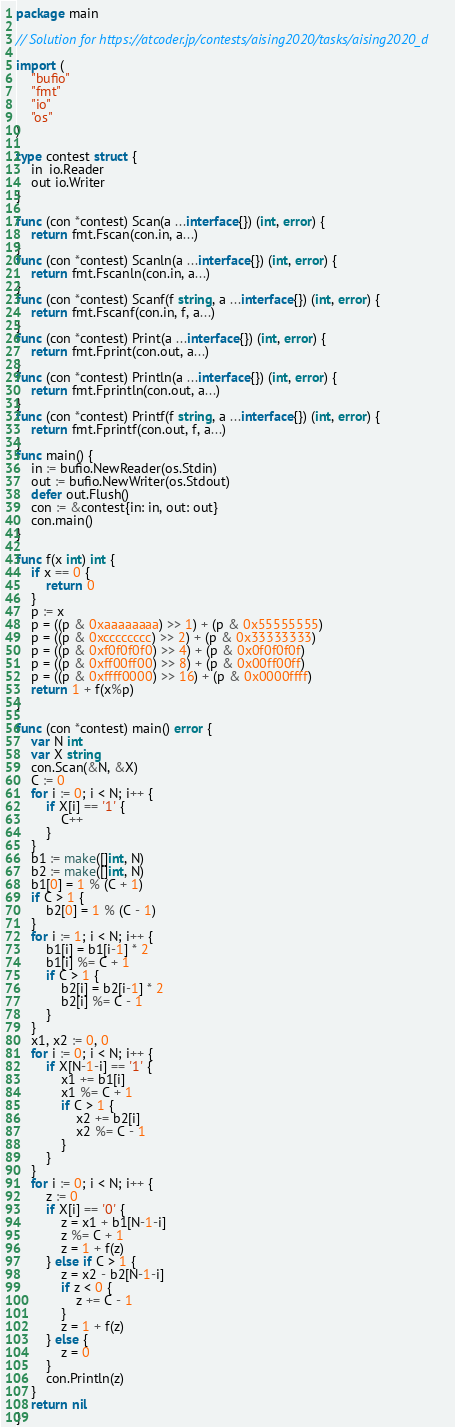Convert code to text. <code><loc_0><loc_0><loc_500><loc_500><_Go_>package main

// Solution for https://atcoder.jp/contests/aising2020/tasks/aising2020_d

import (
	"bufio"
	"fmt"
	"io"
	"os"
)

type contest struct {
	in  io.Reader
	out io.Writer
}

func (con *contest) Scan(a ...interface{}) (int, error) {
	return fmt.Fscan(con.in, a...)
}
func (con *contest) Scanln(a ...interface{}) (int, error) {
	return fmt.Fscanln(con.in, a...)
}
func (con *contest) Scanf(f string, a ...interface{}) (int, error) {
	return fmt.Fscanf(con.in, f, a...)
}
func (con *contest) Print(a ...interface{}) (int, error) {
	return fmt.Fprint(con.out, a...)
}
func (con *contest) Println(a ...interface{}) (int, error) {
	return fmt.Fprintln(con.out, a...)
}
func (con *contest) Printf(f string, a ...interface{}) (int, error) {
	return fmt.Fprintf(con.out, f, a...)
}
func main() {
	in := bufio.NewReader(os.Stdin)
	out := bufio.NewWriter(os.Stdout)
	defer out.Flush()
	con := &contest{in: in, out: out}
	con.main()
}

func f(x int) int {
	if x == 0 {
		return 0
	}
	p := x
	p = ((p & 0xaaaaaaaa) >> 1) + (p & 0x55555555)
	p = ((p & 0xcccccccc) >> 2) + (p & 0x33333333)
	p = ((p & 0xf0f0f0f0) >> 4) + (p & 0x0f0f0f0f)
	p = ((p & 0xff00ff00) >> 8) + (p & 0x00ff00ff)
	p = ((p & 0xffff0000) >> 16) + (p & 0x0000ffff)
	return 1 + f(x%p)
}

func (con *contest) main() error {
	var N int
	var X string
	con.Scan(&N, &X)
	C := 0
	for i := 0; i < N; i++ {
		if X[i] == '1' {
			C++
		}
	}
	b1 := make([]int, N)
	b2 := make([]int, N)
	b1[0] = 1 % (C + 1)
	if C > 1 {
		b2[0] = 1 % (C - 1)
	}
	for i := 1; i < N; i++ {
		b1[i] = b1[i-1] * 2
		b1[i] %= C + 1
		if C > 1 {
			b2[i] = b2[i-1] * 2
			b2[i] %= C - 1
		}
	}
	x1, x2 := 0, 0
	for i := 0; i < N; i++ {
		if X[N-1-i] == '1' {
			x1 += b1[i]
			x1 %= C + 1
			if C > 1 {
				x2 += b2[i]
				x2 %= C - 1
			}
		}
	}
	for i := 0; i < N; i++ {
		z := 0
		if X[i] == '0' {
			z = x1 + b1[N-1-i]
			z %= C + 1
			z = 1 + f(z)
		} else if C > 1 {
			z = x2 - b2[N-1-i]
			if z < 0 {
				z += C - 1
			}
			z = 1 + f(z)
		} else {
			z = 0
		}
		con.Println(z)
	}
	return nil
}
</code> 